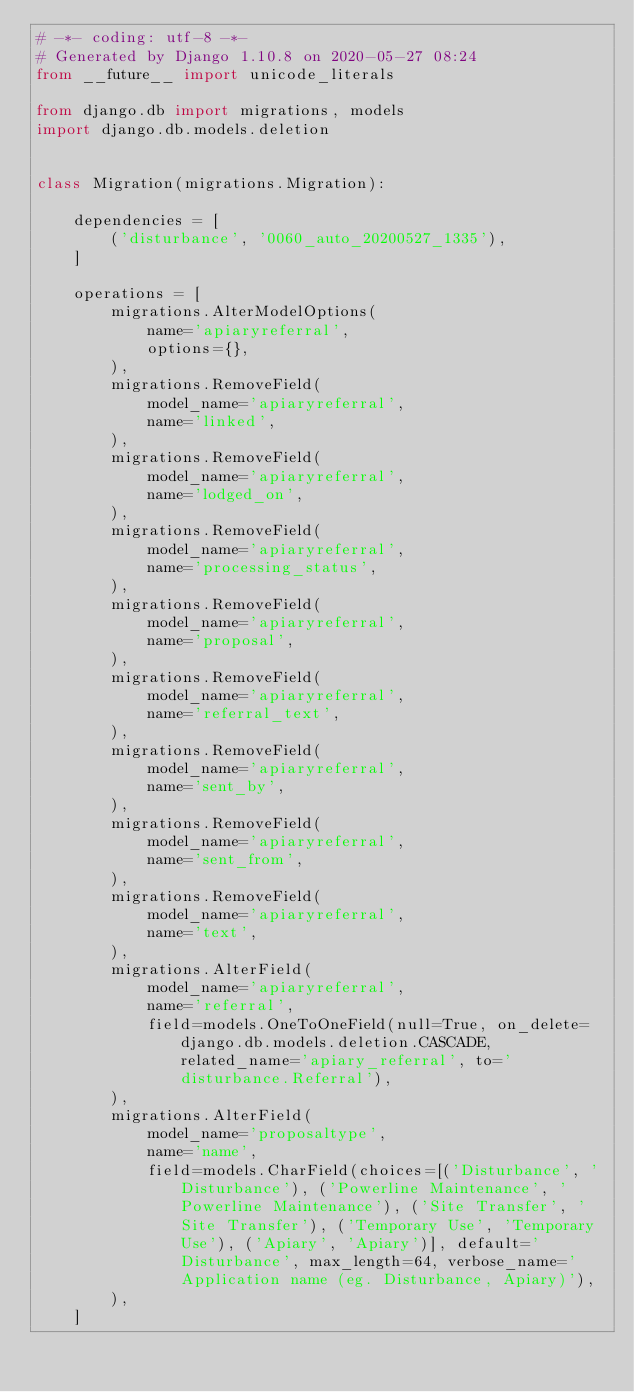<code> <loc_0><loc_0><loc_500><loc_500><_Python_># -*- coding: utf-8 -*-
# Generated by Django 1.10.8 on 2020-05-27 08:24
from __future__ import unicode_literals

from django.db import migrations, models
import django.db.models.deletion


class Migration(migrations.Migration):

    dependencies = [
        ('disturbance', '0060_auto_20200527_1335'),
    ]

    operations = [
        migrations.AlterModelOptions(
            name='apiaryreferral',
            options={},
        ),
        migrations.RemoveField(
            model_name='apiaryreferral',
            name='linked',
        ),
        migrations.RemoveField(
            model_name='apiaryreferral',
            name='lodged_on',
        ),
        migrations.RemoveField(
            model_name='apiaryreferral',
            name='processing_status',
        ),
        migrations.RemoveField(
            model_name='apiaryreferral',
            name='proposal',
        ),
        migrations.RemoveField(
            model_name='apiaryreferral',
            name='referral_text',
        ),
        migrations.RemoveField(
            model_name='apiaryreferral',
            name='sent_by',
        ),
        migrations.RemoveField(
            model_name='apiaryreferral',
            name='sent_from',
        ),
        migrations.RemoveField(
            model_name='apiaryreferral',
            name='text',
        ),
        migrations.AlterField(
            model_name='apiaryreferral',
            name='referral',
            field=models.OneToOneField(null=True, on_delete=django.db.models.deletion.CASCADE, related_name='apiary_referral', to='disturbance.Referral'),
        ),
        migrations.AlterField(
            model_name='proposaltype',
            name='name',
            field=models.CharField(choices=[('Disturbance', 'Disturbance'), ('Powerline Maintenance', 'Powerline Maintenance'), ('Site Transfer', 'Site Transfer'), ('Temporary Use', 'Temporary Use'), ('Apiary', 'Apiary')], default='Disturbance', max_length=64, verbose_name='Application name (eg. Disturbance, Apiary)'),
        ),
    ]
</code> 